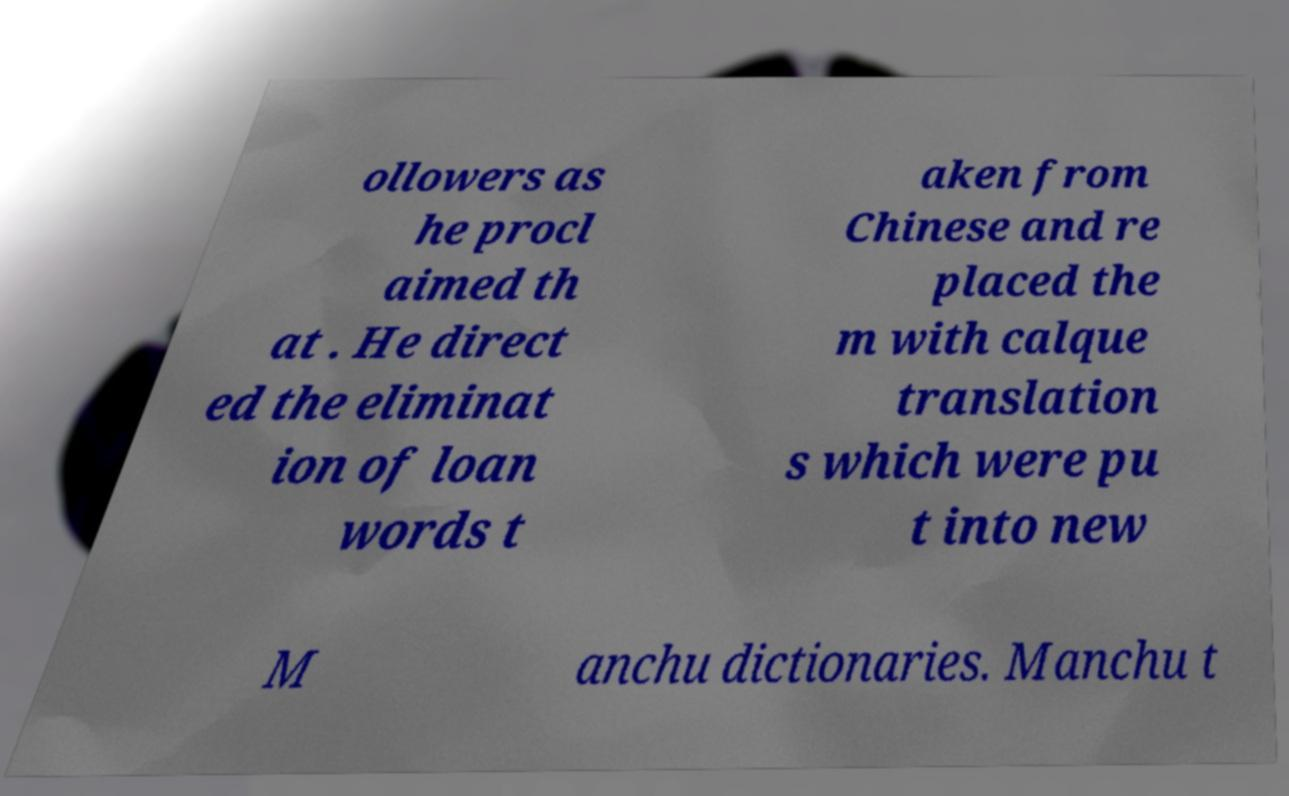Could you extract and type out the text from this image? ollowers as he procl aimed th at . He direct ed the eliminat ion of loan words t aken from Chinese and re placed the m with calque translation s which were pu t into new M anchu dictionaries. Manchu t 